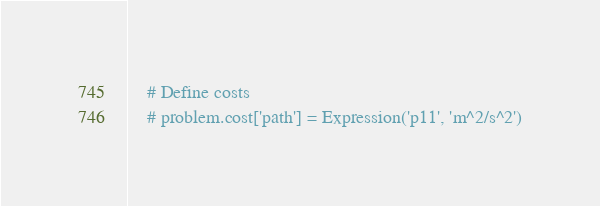Convert code to text. <code><loc_0><loc_0><loc_500><loc_500><_Python_>
    # Define costs
    # problem.cost['path'] = Expression('p11', 'm^2/s^2')</code> 